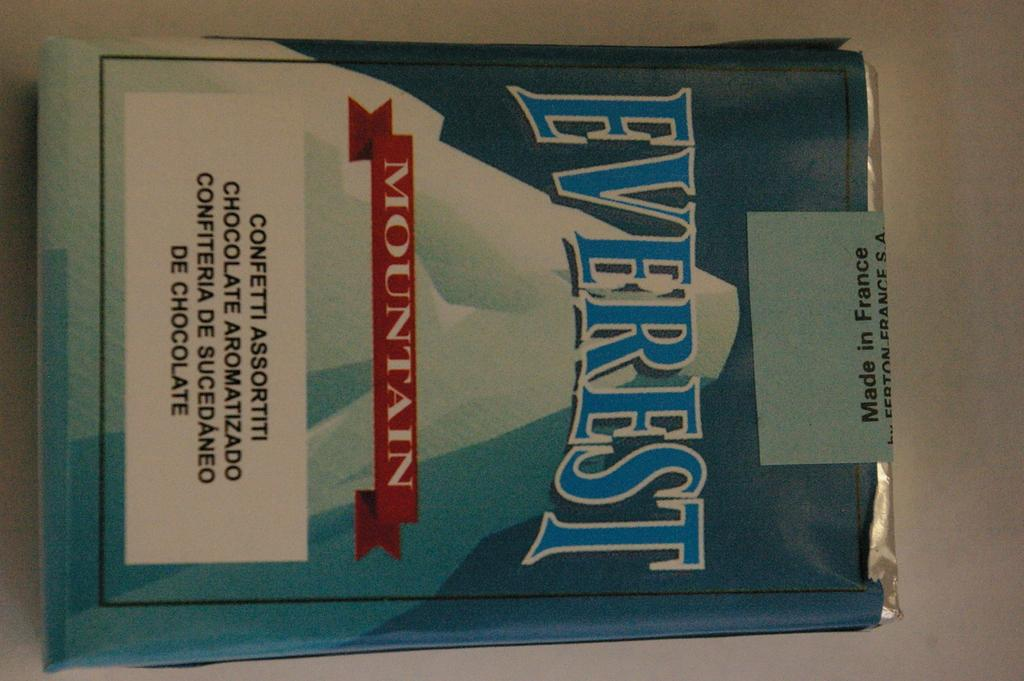<image>
Present a compact description of the photo's key features. Everest Mountain confetti assortiti chocolate aromatizado in blue white wrapper 